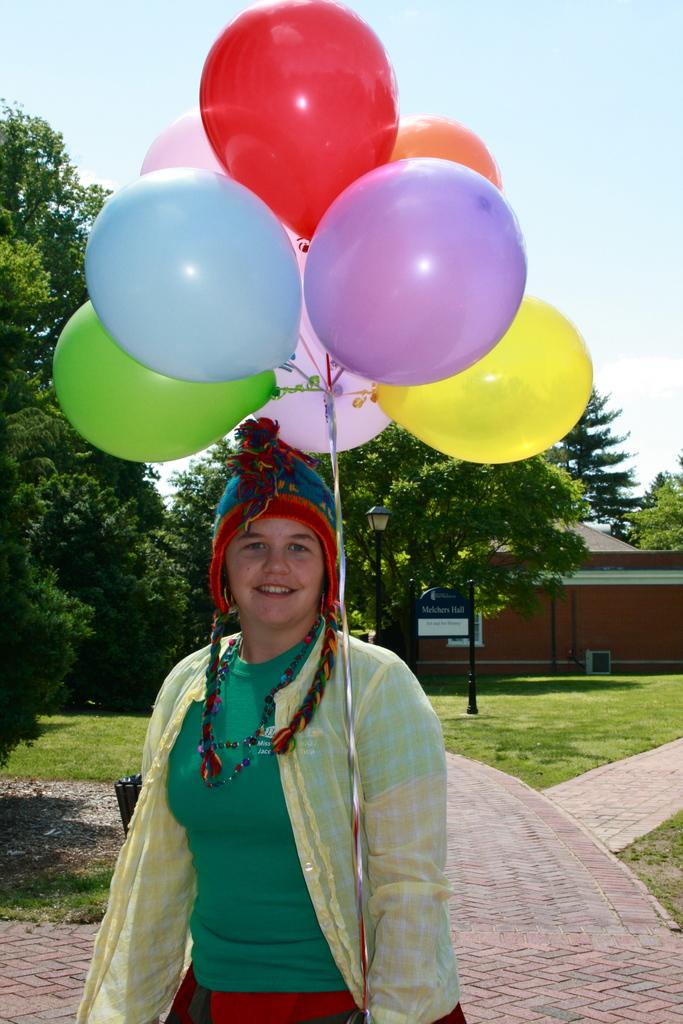What is the woman in the image holding? The woman is holding balloons in her hand. What can be seen in the background of the image? There is a building, a group of trees, moles, a sign board, and the sky visible in the background of the image. What songs is the woman singing in the image? There is no indication in the image that the woman is singing any songs. 